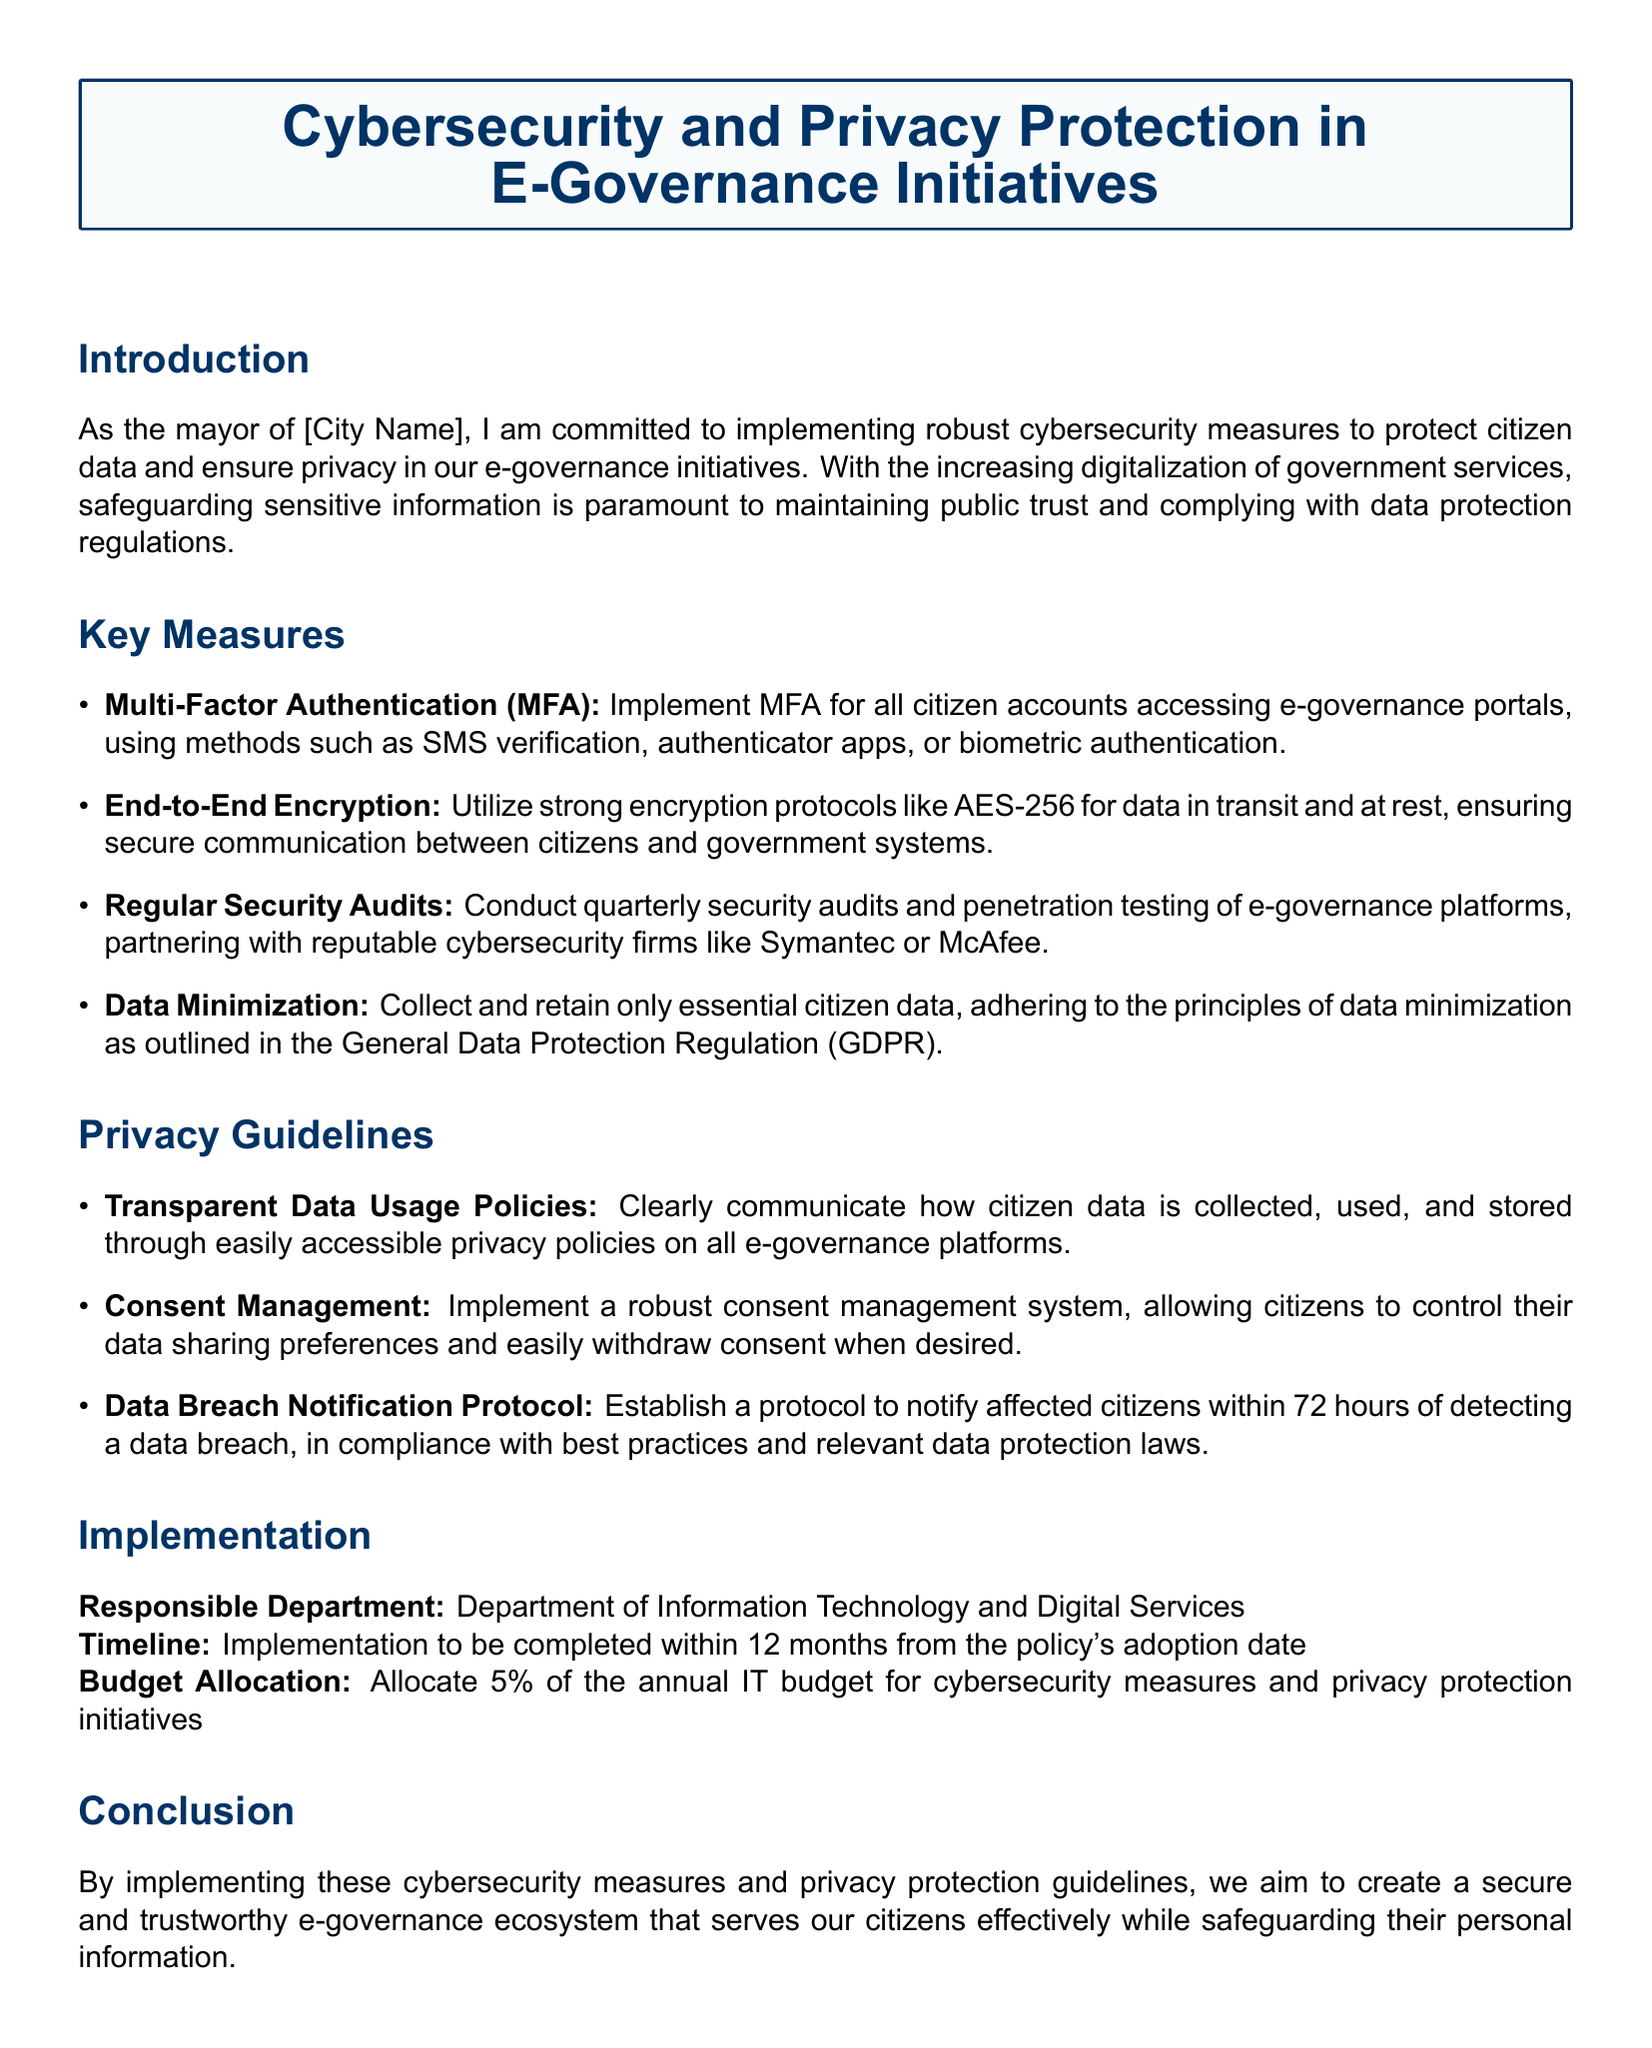What is the title of the document? The title is prominently displayed at the top of the document, encapsulating its main focus.
Answer: Cybersecurity and Privacy Protection in E-Governance Initiatives Who is responsible for implementing the measures? The responsible department is mentioned in the implementation section of the document.
Answer: Department of Information Technology and Digital Services What encryption protocol is recommended? The document specifies the encryption protocol to be used for data protection.
Answer: AES-256 How long is the implementation timeline? The timeline for implementation is provided in the implementation section of the document.
Answer: 12 months What percentage of the IT budget is allocated for cybersecurity? The budget allocation for cybersecurity measures is explicitly stated in the implementation section.
Answer: 5% What is the purpose of the Data Breach Notification Protocol? The purpose is outlined in the privacy guidelines section regarding handling data breaches.
Answer: Notify affected citizens within 72 hours What is one method of Multi-Factor Authentication mentioned? The document lists specific methods for Multi-Factor Authentication to be implemented for citizen accounts.
Answer: Biometric authentication What principle is emphasized in data collection? The document refers to a specific principle that governs how data should be collected and retained.
Answer: Data minimization What should the privacy policies communicate? The document clearly states the expectation for privacy policies regarding data management and usage.
Answer: Data usage policies 